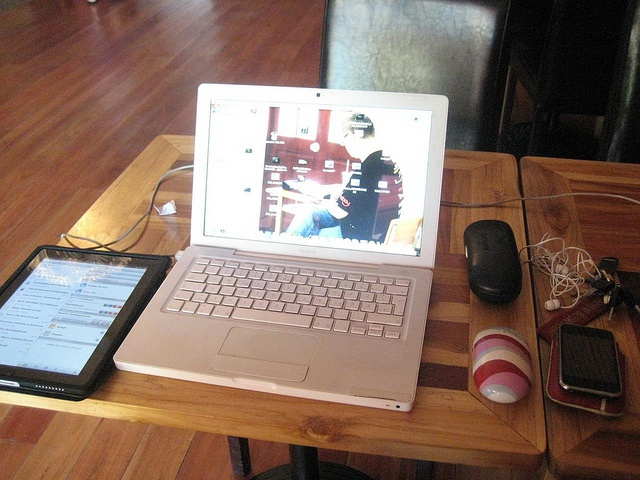Describe the objects in this image and their specific colors. I can see laptop in black, white, darkgray, tan, and gray tones, chair in black, darkgray, gray, and lightgray tones, chair in black, maroon, and brown tones, people in black, white, gray, and darkgray tones, and mouse in black, maroon, and gray tones in this image. 